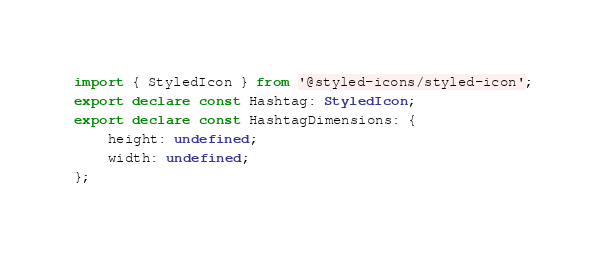Convert code to text. <code><loc_0><loc_0><loc_500><loc_500><_TypeScript_>import { StyledIcon } from '@styled-icons/styled-icon';
export declare const Hashtag: StyledIcon;
export declare const HashtagDimensions: {
    height: undefined;
    width: undefined;
};
</code> 